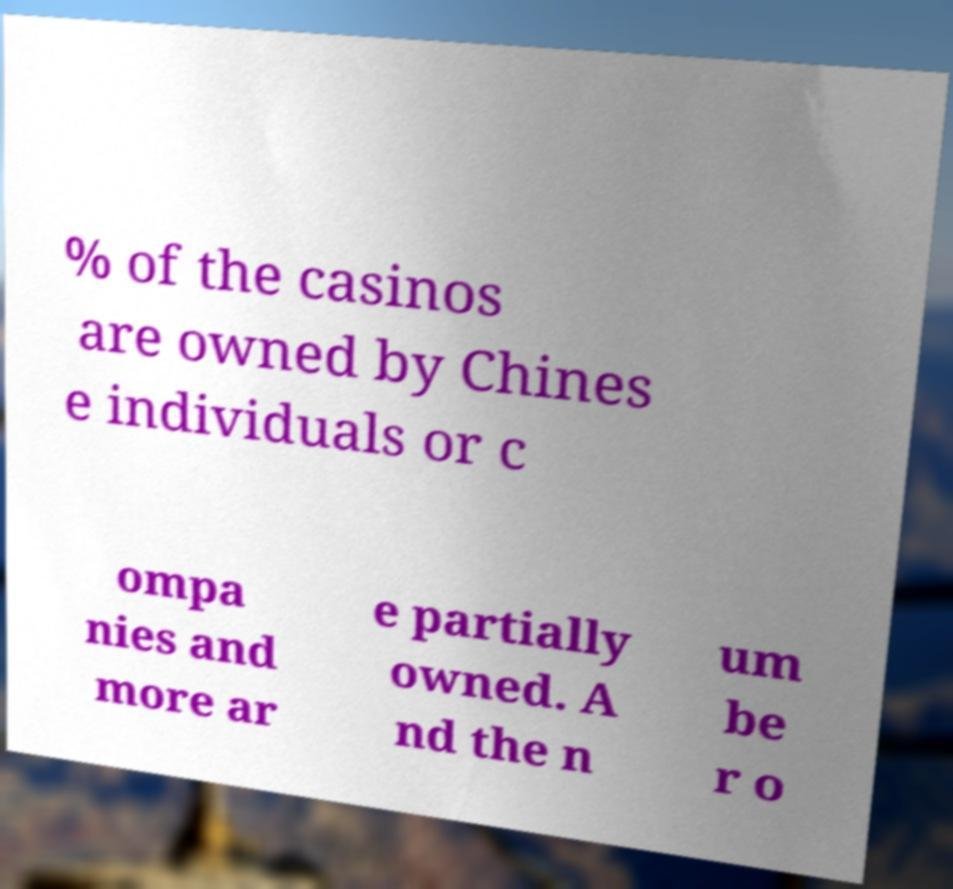I need the written content from this picture converted into text. Can you do that? % of the casinos are owned by Chines e individuals or c ompa nies and more ar e partially owned. A nd the n um be r o 